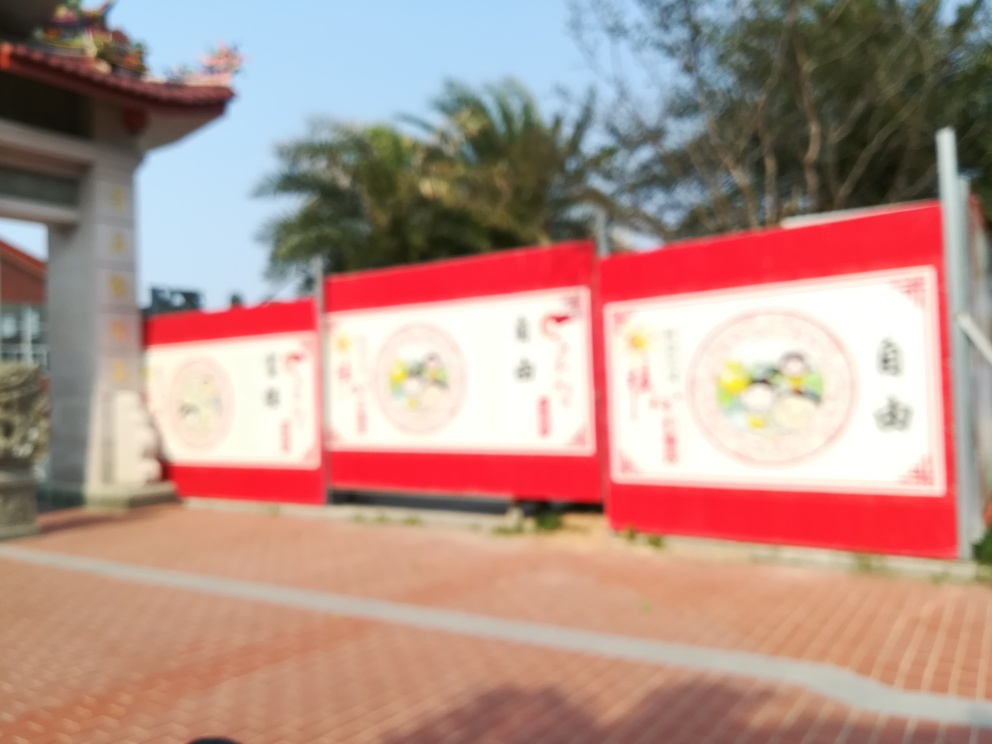Assuming this is an advertisement, what kind of products or services do you think it might be promoting, based on its design? Although the focus is not clear, the use of vibrant colors and what appears to be imagery possibly related to nature or well-being could suggest that the billboard is promoting products or services associated with health, outdoor activities, or perhaps a cultural festival or event. 